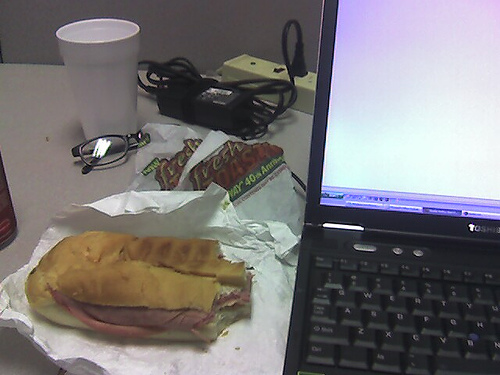What might be the occupation of the person owning the laptop? Judging by the combination of the laptop, the casual arrangement of lunch, and sunglasses, this could belong to a busy professional, perhaps someone in an office setting who is taking a lunch break while working. 